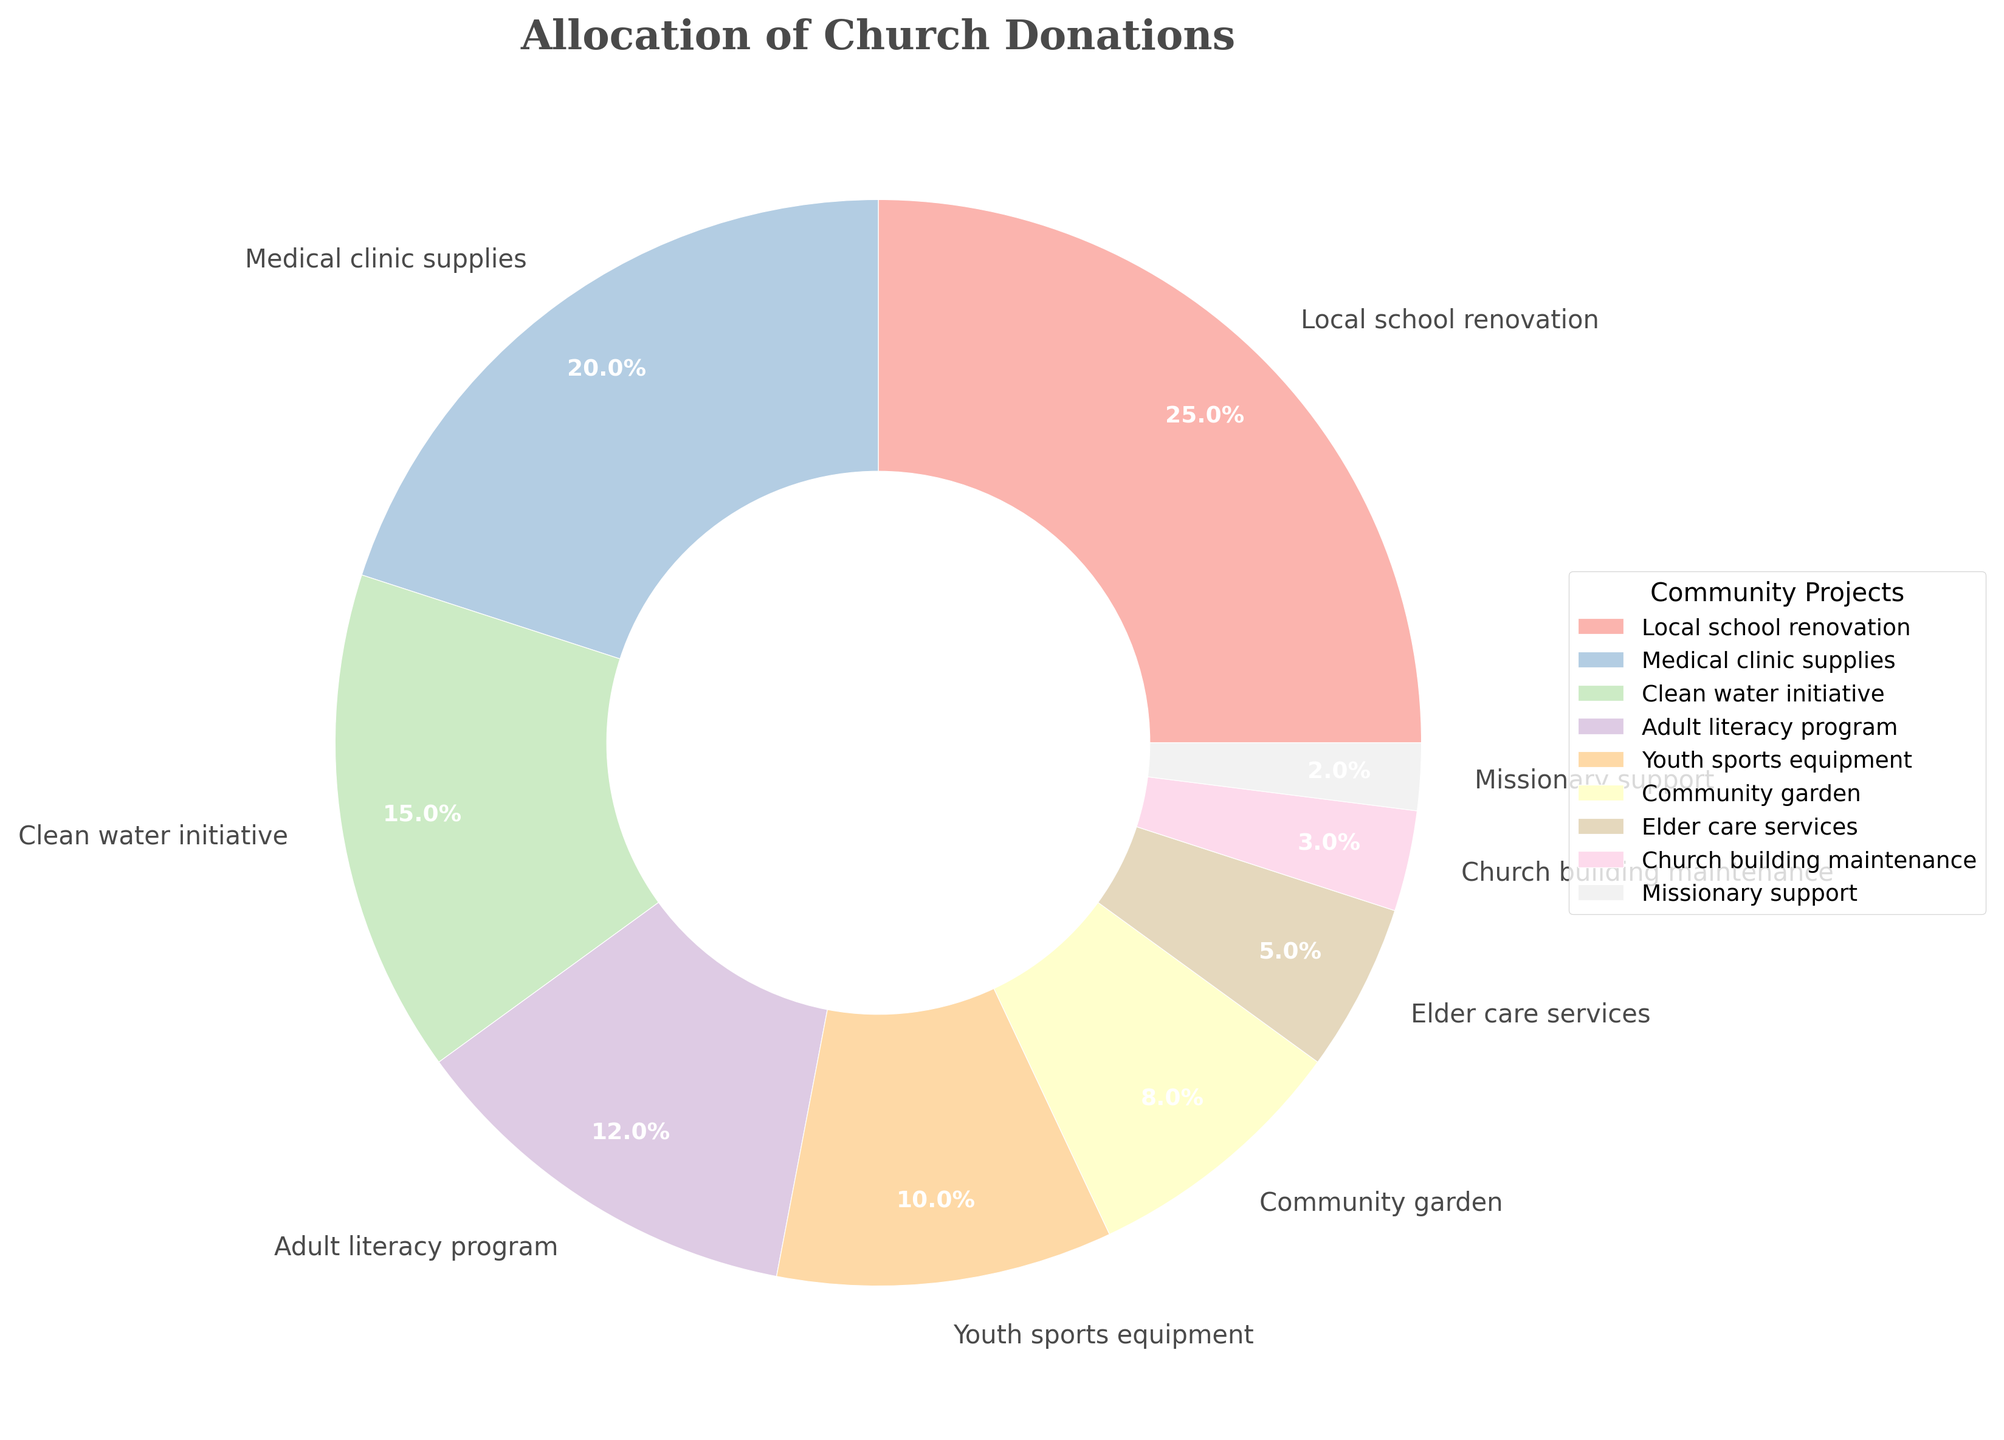What is the community project receiving the highest percentage of church donations? Identify the largest slice in the pie chart and refer to its label. The largest slice corresponds to the "Local school renovation" project.
Answer: Local school renovation Which projects receive less than 10% of the total donations individually? Look for the slices of the pie chart that have percentages less than 10%. These include "Community garden," "Elder care services," "Church building maintenance," and "Missionary support."
Answer: Community garden, Elder care services, Church building maintenance, Missionary support How much more percentage of donations does the Local school renovation project get compared to the Medical clinic supplies project? Find the difference between the percentages allocated to "Local school renovation" (25%) and "Medical clinic supplies" (20%). This is calculated as 25% - 20% = 5%.
Answer: 5% If you combine the percentage of donations for the Adult literacy program and Youth sports equipment, what is the total? Add the percentages of "Adult literacy program" (12%) and "Youth sports equipment" (10%). This results in 12% + 10% = 22%.
Answer: 22% Which project receives the lowest percentage of the donations? Identify the smallest slice in the pie chart and refer to its label. The smallest slice corresponds to the "Missionary support" project.
Answer: Missionary support Are there more projects receiving 10% or more donations, or less than 10% donations? Count the number of projects with percentages 10% or more (Local school renovation, Medical clinic supplies, Clean water initiative, Adult literacy program, Youth sports equipment) and less than 10% (Community garden, Elder care services, Church building maintenance, Missionary support). There are 5 projects receiving 10% or more and 4 projects receiving less than 10%.
Answer: More projects receiving 10% or more Which project receives more donations: the Community garden or the Clean water initiative? Compare the percentages for "Community garden" (8%) and "Clean water initiative" (15%). The Clean water initiative receives a higher percentage of donations.
Answer: Clean water initiative What is the average percentage allocation for Community garden, Elder care services, Church building maintenance, and Missionary support combined? Find the sum of the percentages (8% + 5% + 3% + 2%) and then divide by the number of projects (4). This is calculated as (8% + 5% + 3% + 2%) / 4 = 18% / 4 = 4.5%.
Answer: 4.5% If donations to the Youth sports equipment project were to be doubled, what would be the new percentage allocation? Double the current percentage for Youth sports equipment (10% * 2). The new percentage would be 20%.
Answer: 20% How does the percentage for Church building maintenance compare to Elder care services? Compare the percentages for "Church building maintenance" (3%) and "Elder care services" (5%). Church building maintenance receives a lower percentage of donations compared to Elder care services.
Answer: Church building maintenance receives less 